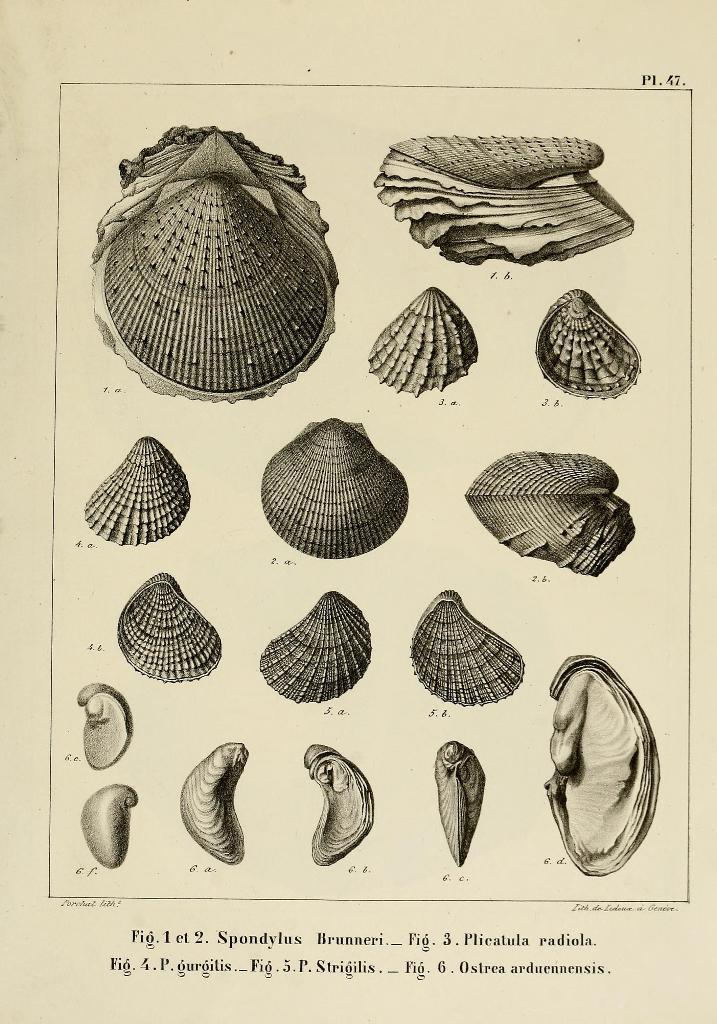What type of objects are present in the image? The image contains seashells. Can you describe the variety of seashells in the image? There are different kinds of seashells in the image. Is there any text associated with the image? Yes, there is text at the bottom of the image. Who is the owner of the cracker in the image? There is no cracker present in the image. What type of pest can be seen crawling on the seashells in the image? There are no pests visible in the image; it only contains seashells and text. 